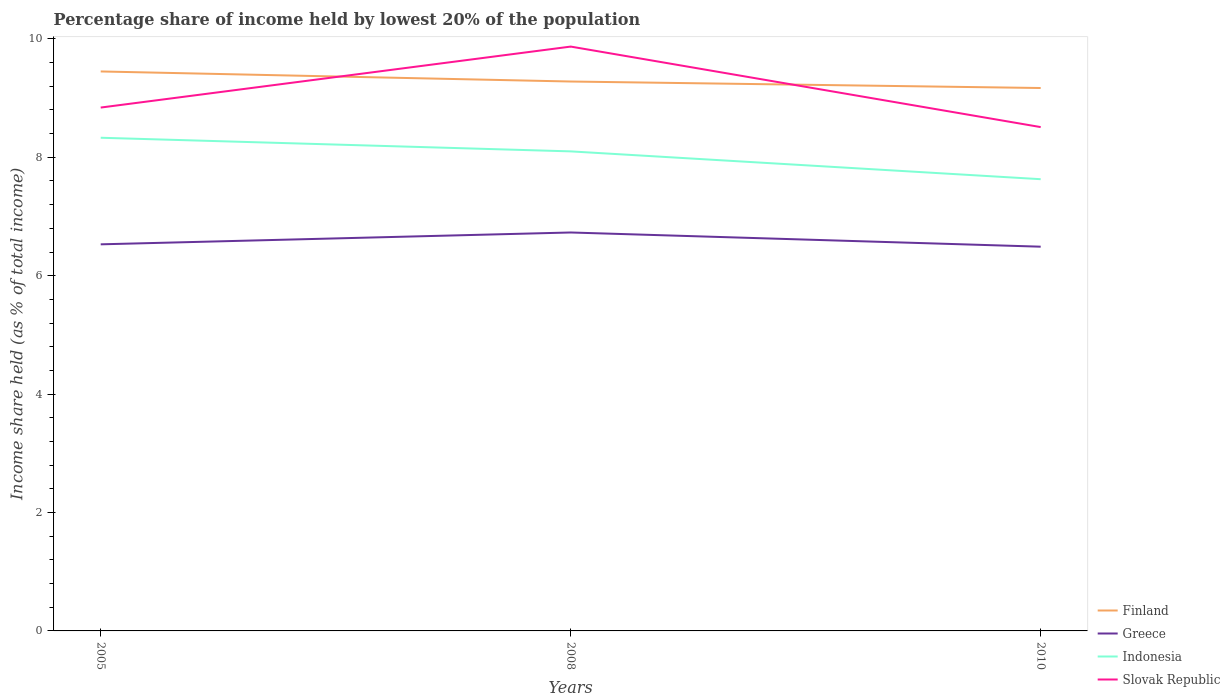How many different coloured lines are there?
Make the answer very short. 4. Is the number of lines equal to the number of legend labels?
Provide a succinct answer. Yes. Across all years, what is the maximum percentage share of income held by lowest 20% of the population in Finland?
Give a very brief answer. 9.17. In which year was the percentage share of income held by lowest 20% of the population in Finland maximum?
Offer a very short reply. 2010. What is the total percentage share of income held by lowest 20% of the population in Greece in the graph?
Provide a short and direct response. -0.2. What is the difference between the highest and the second highest percentage share of income held by lowest 20% of the population in Indonesia?
Offer a terse response. 0.7. Is the percentage share of income held by lowest 20% of the population in Greece strictly greater than the percentage share of income held by lowest 20% of the population in Finland over the years?
Make the answer very short. Yes. What is the difference between two consecutive major ticks on the Y-axis?
Offer a terse response. 2. Are the values on the major ticks of Y-axis written in scientific E-notation?
Keep it short and to the point. No. Does the graph contain any zero values?
Your response must be concise. No. Does the graph contain grids?
Give a very brief answer. No. Where does the legend appear in the graph?
Your response must be concise. Bottom right. How many legend labels are there?
Provide a short and direct response. 4. What is the title of the graph?
Make the answer very short. Percentage share of income held by lowest 20% of the population. Does "Cote d'Ivoire" appear as one of the legend labels in the graph?
Your answer should be compact. No. What is the label or title of the X-axis?
Provide a succinct answer. Years. What is the label or title of the Y-axis?
Offer a very short reply. Income share held (as % of total income). What is the Income share held (as % of total income) in Finland in 2005?
Your response must be concise. 9.45. What is the Income share held (as % of total income) in Greece in 2005?
Your response must be concise. 6.53. What is the Income share held (as % of total income) in Indonesia in 2005?
Make the answer very short. 8.33. What is the Income share held (as % of total income) of Slovak Republic in 2005?
Your answer should be very brief. 8.84. What is the Income share held (as % of total income) of Finland in 2008?
Your answer should be compact. 9.28. What is the Income share held (as % of total income) of Greece in 2008?
Make the answer very short. 6.73. What is the Income share held (as % of total income) in Indonesia in 2008?
Make the answer very short. 8.1. What is the Income share held (as % of total income) in Slovak Republic in 2008?
Keep it short and to the point. 9.87. What is the Income share held (as % of total income) in Finland in 2010?
Make the answer very short. 9.17. What is the Income share held (as % of total income) of Greece in 2010?
Keep it short and to the point. 6.49. What is the Income share held (as % of total income) of Indonesia in 2010?
Your response must be concise. 7.63. What is the Income share held (as % of total income) in Slovak Republic in 2010?
Offer a terse response. 8.51. Across all years, what is the maximum Income share held (as % of total income) of Finland?
Offer a terse response. 9.45. Across all years, what is the maximum Income share held (as % of total income) of Greece?
Your response must be concise. 6.73. Across all years, what is the maximum Income share held (as % of total income) in Indonesia?
Offer a very short reply. 8.33. Across all years, what is the maximum Income share held (as % of total income) in Slovak Republic?
Your answer should be very brief. 9.87. Across all years, what is the minimum Income share held (as % of total income) of Finland?
Your response must be concise. 9.17. Across all years, what is the minimum Income share held (as % of total income) in Greece?
Offer a very short reply. 6.49. Across all years, what is the minimum Income share held (as % of total income) of Indonesia?
Your response must be concise. 7.63. Across all years, what is the minimum Income share held (as % of total income) of Slovak Republic?
Provide a succinct answer. 8.51. What is the total Income share held (as % of total income) of Finland in the graph?
Offer a very short reply. 27.9. What is the total Income share held (as % of total income) of Greece in the graph?
Provide a short and direct response. 19.75. What is the total Income share held (as % of total income) of Indonesia in the graph?
Ensure brevity in your answer.  24.06. What is the total Income share held (as % of total income) in Slovak Republic in the graph?
Offer a terse response. 27.22. What is the difference between the Income share held (as % of total income) in Finland in 2005 and that in 2008?
Ensure brevity in your answer.  0.17. What is the difference between the Income share held (as % of total income) of Indonesia in 2005 and that in 2008?
Your answer should be compact. 0.23. What is the difference between the Income share held (as % of total income) of Slovak Republic in 2005 and that in 2008?
Keep it short and to the point. -1.03. What is the difference between the Income share held (as % of total income) of Finland in 2005 and that in 2010?
Your response must be concise. 0.28. What is the difference between the Income share held (as % of total income) in Greece in 2005 and that in 2010?
Give a very brief answer. 0.04. What is the difference between the Income share held (as % of total income) in Slovak Republic in 2005 and that in 2010?
Provide a short and direct response. 0.33. What is the difference between the Income share held (as % of total income) in Finland in 2008 and that in 2010?
Your answer should be very brief. 0.11. What is the difference between the Income share held (as % of total income) in Greece in 2008 and that in 2010?
Offer a very short reply. 0.24. What is the difference between the Income share held (as % of total income) in Indonesia in 2008 and that in 2010?
Your answer should be compact. 0.47. What is the difference between the Income share held (as % of total income) of Slovak Republic in 2008 and that in 2010?
Keep it short and to the point. 1.36. What is the difference between the Income share held (as % of total income) of Finland in 2005 and the Income share held (as % of total income) of Greece in 2008?
Keep it short and to the point. 2.72. What is the difference between the Income share held (as % of total income) of Finland in 2005 and the Income share held (as % of total income) of Indonesia in 2008?
Provide a short and direct response. 1.35. What is the difference between the Income share held (as % of total income) in Finland in 2005 and the Income share held (as % of total income) in Slovak Republic in 2008?
Give a very brief answer. -0.42. What is the difference between the Income share held (as % of total income) of Greece in 2005 and the Income share held (as % of total income) of Indonesia in 2008?
Provide a succinct answer. -1.57. What is the difference between the Income share held (as % of total income) of Greece in 2005 and the Income share held (as % of total income) of Slovak Republic in 2008?
Give a very brief answer. -3.34. What is the difference between the Income share held (as % of total income) of Indonesia in 2005 and the Income share held (as % of total income) of Slovak Republic in 2008?
Your answer should be compact. -1.54. What is the difference between the Income share held (as % of total income) in Finland in 2005 and the Income share held (as % of total income) in Greece in 2010?
Offer a very short reply. 2.96. What is the difference between the Income share held (as % of total income) in Finland in 2005 and the Income share held (as % of total income) in Indonesia in 2010?
Provide a succinct answer. 1.82. What is the difference between the Income share held (as % of total income) of Finland in 2005 and the Income share held (as % of total income) of Slovak Republic in 2010?
Your answer should be compact. 0.94. What is the difference between the Income share held (as % of total income) of Greece in 2005 and the Income share held (as % of total income) of Slovak Republic in 2010?
Provide a succinct answer. -1.98. What is the difference between the Income share held (as % of total income) of Indonesia in 2005 and the Income share held (as % of total income) of Slovak Republic in 2010?
Offer a terse response. -0.18. What is the difference between the Income share held (as % of total income) of Finland in 2008 and the Income share held (as % of total income) of Greece in 2010?
Offer a terse response. 2.79. What is the difference between the Income share held (as % of total income) of Finland in 2008 and the Income share held (as % of total income) of Indonesia in 2010?
Your response must be concise. 1.65. What is the difference between the Income share held (as % of total income) in Finland in 2008 and the Income share held (as % of total income) in Slovak Republic in 2010?
Your response must be concise. 0.77. What is the difference between the Income share held (as % of total income) in Greece in 2008 and the Income share held (as % of total income) in Slovak Republic in 2010?
Offer a very short reply. -1.78. What is the difference between the Income share held (as % of total income) of Indonesia in 2008 and the Income share held (as % of total income) of Slovak Republic in 2010?
Give a very brief answer. -0.41. What is the average Income share held (as % of total income) of Finland per year?
Offer a very short reply. 9.3. What is the average Income share held (as % of total income) of Greece per year?
Keep it short and to the point. 6.58. What is the average Income share held (as % of total income) of Indonesia per year?
Give a very brief answer. 8.02. What is the average Income share held (as % of total income) of Slovak Republic per year?
Provide a succinct answer. 9.07. In the year 2005, what is the difference between the Income share held (as % of total income) in Finland and Income share held (as % of total income) in Greece?
Your response must be concise. 2.92. In the year 2005, what is the difference between the Income share held (as % of total income) of Finland and Income share held (as % of total income) of Indonesia?
Offer a terse response. 1.12. In the year 2005, what is the difference between the Income share held (as % of total income) of Finland and Income share held (as % of total income) of Slovak Republic?
Your answer should be very brief. 0.61. In the year 2005, what is the difference between the Income share held (as % of total income) in Greece and Income share held (as % of total income) in Slovak Republic?
Make the answer very short. -2.31. In the year 2005, what is the difference between the Income share held (as % of total income) of Indonesia and Income share held (as % of total income) of Slovak Republic?
Offer a terse response. -0.51. In the year 2008, what is the difference between the Income share held (as % of total income) of Finland and Income share held (as % of total income) of Greece?
Ensure brevity in your answer.  2.55. In the year 2008, what is the difference between the Income share held (as % of total income) in Finland and Income share held (as % of total income) in Indonesia?
Provide a short and direct response. 1.18. In the year 2008, what is the difference between the Income share held (as % of total income) in Finland and Income share held (as % of total income) in Slovak Republic?
Make the answer very short. -0.59. In the year 2008, what is the difference between the Income share held (as % of total income) in Greece and Income share held (as % of total income) in Indonesia?
Your answer should be very brief. -1.37. In the year 2008, what is the difference between the Income share held (as % of total income) of Greece and Income share held (as % of total income) of Slovak Republic?
Give a very brief answer. -3.14. In the year 2008, what is the difference between the Income share held (as % of total income) in Indonesia and Income share held (as % of total income) in Slovak Republic?
Provide a short and direct response. -1.77. In the year 2010, what is the difference between the Income share held (as % of total income) of Finland and Income share held (as % of total income) of Greece?
Ensure brevity in your answer.  2.68. In the year 2010, what is the difference between the Income share held (as % of total income) in Finland and Income share held (as % of total income) in Indonesia?
Your response must be concise. 1.54. In the year 2010, what is the difference between the Income share held (as % of total income) in Finland and Income share held (as % of total income) in Slovak Republic?
Make the answer very short. 0.66. In the year 2010, what is the difference between the Income share held (as % of total income) of Greece and Income share held (as % of total income) of Indonesia?
Offer a very short reply. -1.14. In the year 2010, what is the difference between the Income share held (as % of total income) of Greece and Income share held (as % of total income) of Slovak Republic?
Your answer should be compact. -2.02. In the year 2010, what is the difference between the Income share held (as % of total income) in Indonesia and Income share held (as % of total income) in Slovak Republic?
Ensure brevity in your answer.  -0.88. What is the ratio of the Income share held (as % of total income) in Finland in 2005 to that in 2008?
Give a very brief answer. 1.02. What is the ratio of the Income share held (as % of total income) of Greece in 2005 to that in 2008?
Provide a short and direct response. 0.97. What is the ratio of the Income share held (as % of total income) in Indonesia in 2005 to that in 2008?
Ensure brevity in your answer.  1.03. What is the ratio of the Income share held (as % of total income) in Slovak Republic in 2005 to that in 2008?
Offer a very short reply. 0.9. What is the ratio of the Income share held (as % of total income) of Finland in 2005 to that in 2010?
Your answer should be compact. 1.03. What is the ratio of the Income share held (as % of total income) of Greece in 2005 to that in 2010?
Your answer should be very brief. 1.01. What is the ratio of the Income share held (as % of total income) in Indonesia in 2005 to that in 2010?
Offer a terse response. 1.09. What is the ratio of the Income share held (as % of total income) in Slovak Republic in 2005 to that in 2010?
Provide a succinct answer. 1.04. What is the ratio of the Income share held (as % of total income) of Greece in 2008 to that in 2010?
Provide a short and direct response. 1.04. What is the ratio of the Income share held (as % of total income) in Indonesia in 2008 to that in 2010?
Offer a very short reply. 1.06. What is the ratio of the Income share held (as % of total income) in Slovak Republic in 2008 to that in 2010?
Give a very brief answer. 1.16. What is the difference between the highest and the second highest Income share held (as % of total income) of Finland?
Make the answer very short. 0.17. What is the difference between the highest and the second highest Income share held (as % of total income) in Indonesia?
Your response must be concise. 0.23. What is the difference between the highest and the lowest Income share held (as % of total income) in Finland?
Provide a succinct answer. 0.28. What is the difference between the highest and the lowest Income share held (as % of total income) in Greece?
Ensure brevity in your answer.  0.24. What is the difference between the highest and the lowest Income share held (as % of total income) in Slovak Republic?
Your response must be concise. 1.36. 